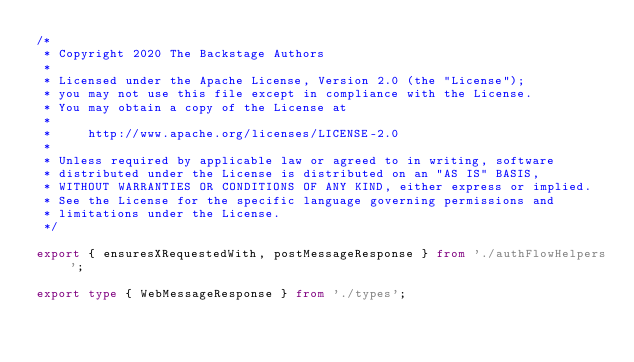<code> <loc_0><loc_0><loc_500><loc_500><_TypeScript_>/*
 * Copyright 2020 The Backstage Authors
 *
 * Licensed under the Apache License, Version 2.0 (the "License");
 * you may not use this file except in compliance with the License.
 * You may obtain a copy of the License at
 *
 *     http://www.apache.org/licenses/LICENSE-2.0
 *
 * Unless required by applicable law or agreed to in writing, software
 * distributed under the License is distributed on an "AS IS" BASIS,
 * WITHOUT WARRANTIES OR CONDITIONS OF ANY KIND, either express or implied.
 * See the License for the specific language governing permissions and
 * limitations under the License.
 */

export { ensuresXRequestedWith, postMessageResponse } from './authFlowHelpers';

export type { WebMessageResponse } from './types';
</code> 